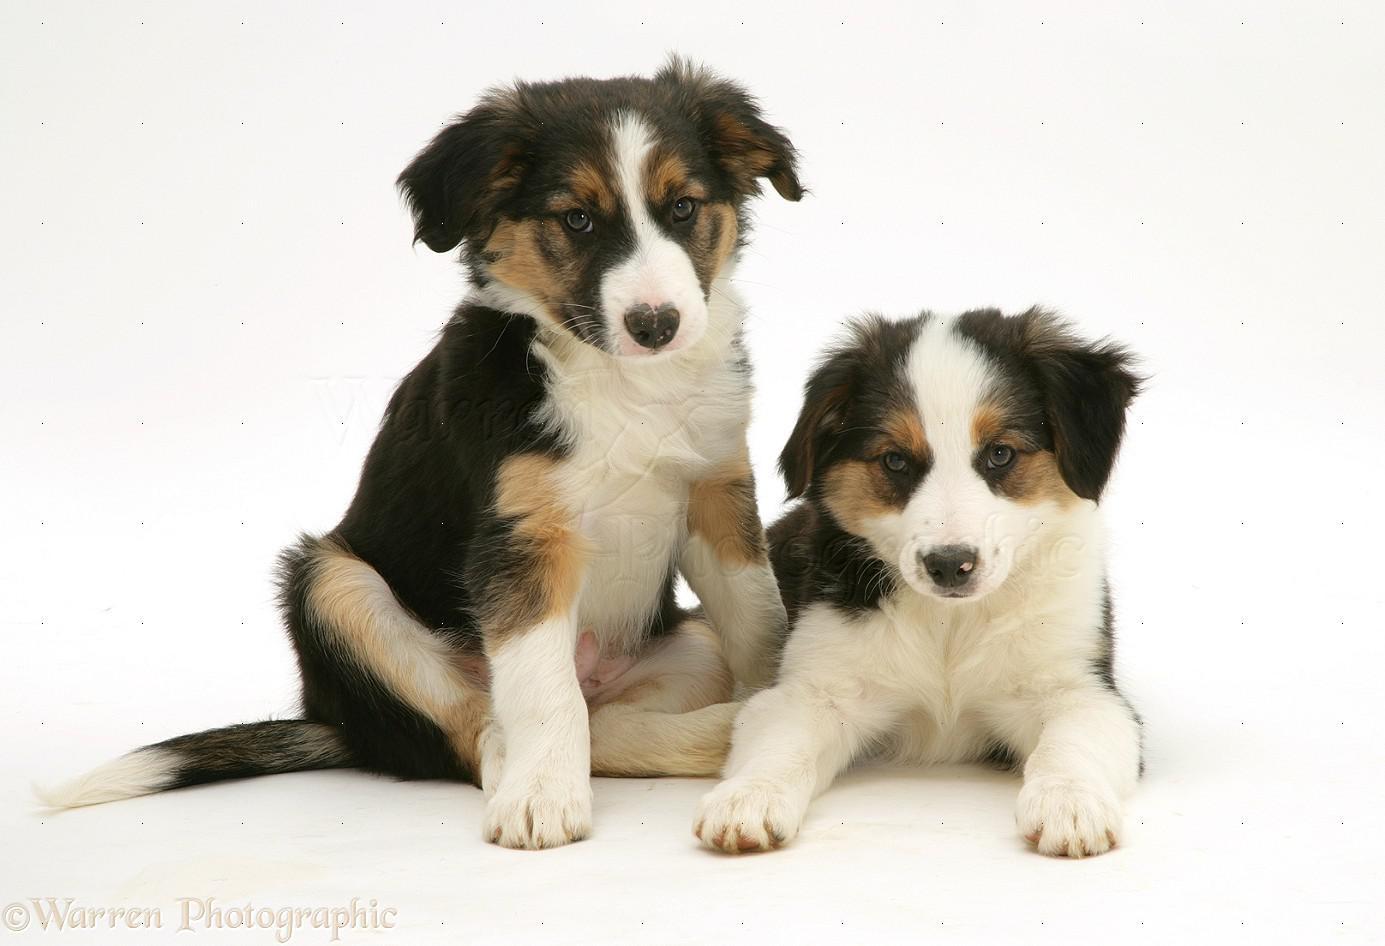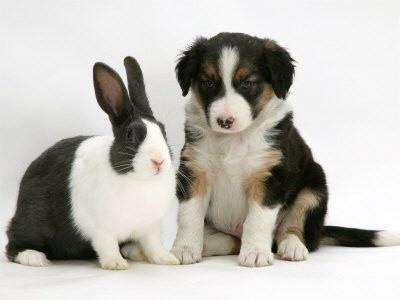The first image is the image on the left, the second image is the image on the right. Given the left and right images, does the statement "One of the pups is on the sidewalk." hold true? Answer yes or no. No. 